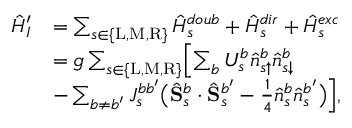Convert formula to latex. <formula><loc_0><loc_0><loc_500><loc_500>\begin{array} { r l } { \hat { H } _ { I } ^ { \prime } } & { = \sum _ { s \in \{ L , M , R \} } \hat { H } _ { s } ^ { d o u b } + \hat { H } _ { s } ^ { d i r } + \hat { H } _ { s } ^ { e x c } } \\ & { = g \sum _ { s \in \{ L , M , R \} } \left [ \sum _ { b } U _ { s } ^ { b } \hat { n } _ { s \uparrow } ^ { b } \hat { n } _ { s \downarrow } ^ { b } } \\ & { - \sum _ { b \neq b ^ { \prime } } J _ { s } ^ { b b ^ { \prime } } \left ( \hat { S } _ { s } ^ { b } \cdot \hat { S } _ { s } ^ { b ^ { \prime } } - \frac { 1 } { 4 } \hat { n } _ { s } ^ { b } \hat { n } _ { s } ^ { b ^ { \prime } } \right ) \right ] , } \end{array}</formula> 